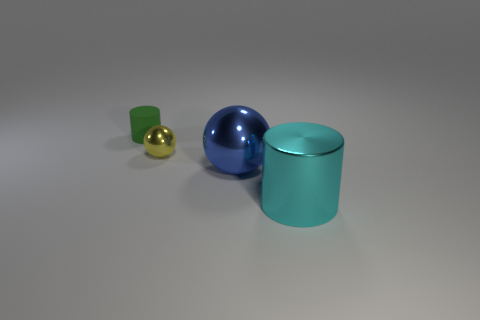Add 1 big blue metallic spheres. How many objects exist? 5 Subtract all green matte things. Subtract all tiny cylinders. How many objects are left? 2 Add 4 yellow metallic spheres. How many yellow metallic spheres are left? 5 Add 2 green rubber things. How many green rubber things exist? 3 Subtract 1 cyan cylinders. How many objects are left? 3 